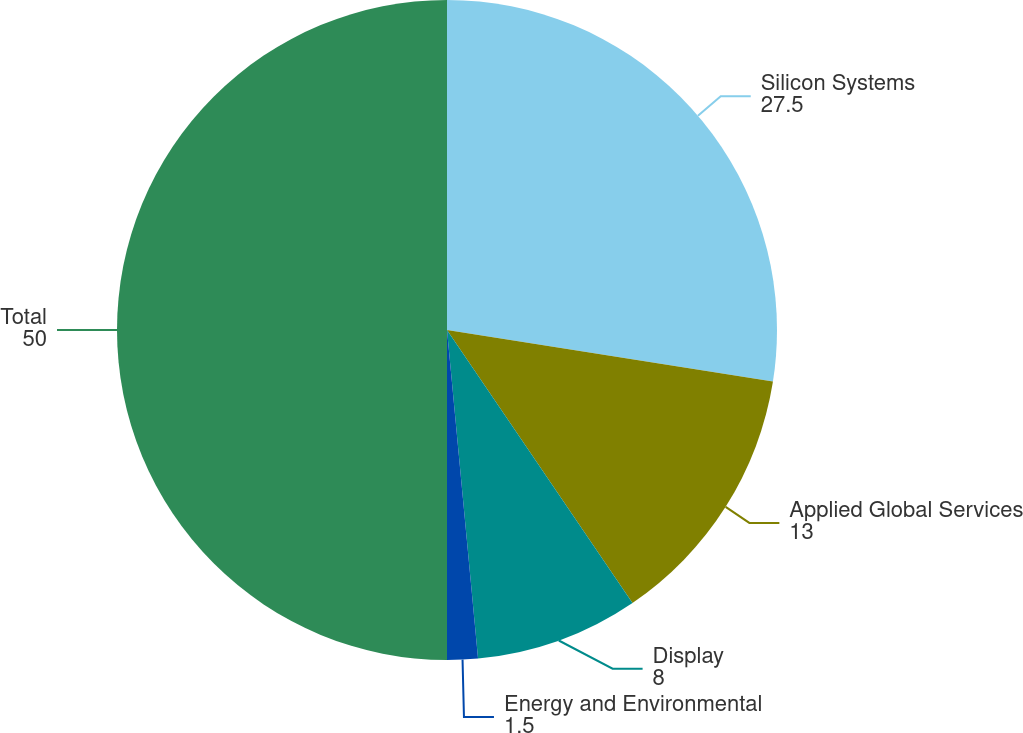Convert chart. <chart><loc_0><loc_0><loc_500><loc_500><pie_chart><fcel>Silicon Systems<fcel>Applied Global Services<fcel>Display<fcel>Energy and Environmental<fcel>Total<nl><fcel>27.5%<fcel>13.0%<fcel>8.0%<fcel>1.5%<fcel>50.0%<nl></chart> 